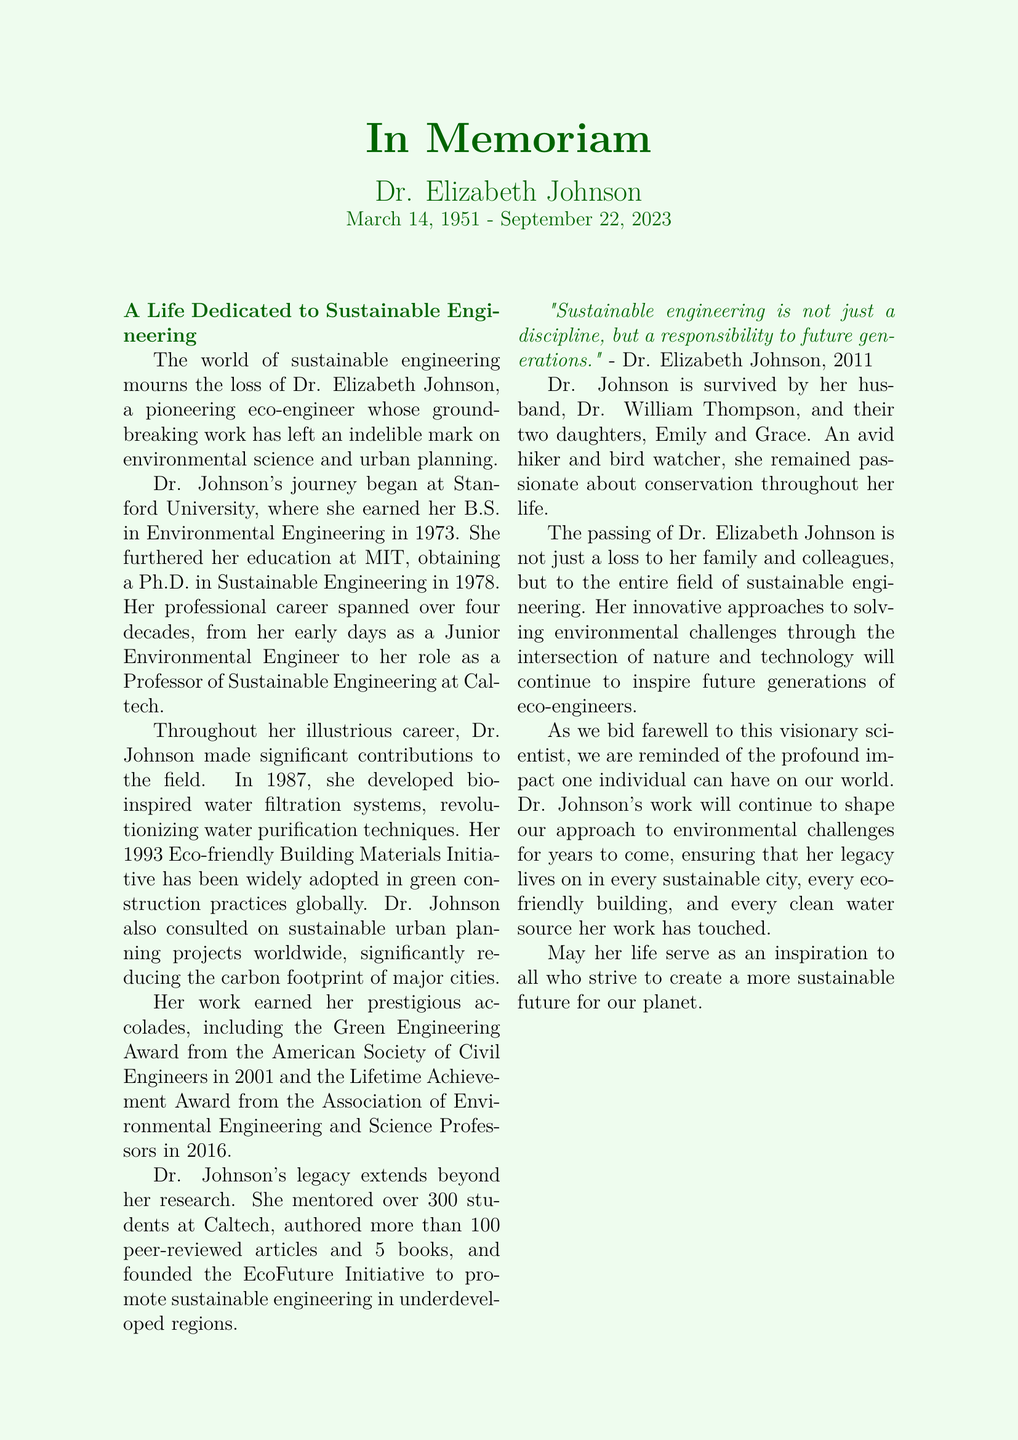What was Dr. Johnson's birth date? The document states that Dr. Elizabeth Johnson was born on March 14, 1951.
Answer: March 14, 1951 How many peer-reviewed articles did Dr. Johnson author? The document mentions that Dr. Johnson authored more than 100 peer-reviewed articles.
Answer: More than 100 What award did Dr. Johnson receive in 2001? The document lists the Green Engineering Award from the American Society of Civil Engineers as an accolade given to Dr. Johnson in 2001.
Answer: Green Engineering Award What was the name of the initiative Dr. Johnson founded? The document refers to the EcoFuture Initiative as the initiative founded by Dr. Johnson.
Answer: EcoFuture Initiative How many students did Dr. Johnson mentor? The document indicates that Dr. Johnson mentored over 300 students at Caltech.
Answer: Over 300 What was Dr. Johnson passionate about outside of her work? The document describes her as an avid hiker and bird watcher, highlighting her passion for conservation.
Answer: Conservation What university did Dr. Johnson attend for her Ph.D.? The document states that Dr. Johnson obtained her Ph.D. at MIT.
Answer: MIT What year did Dr. Johnson develop bio-inspired water filtration systems? The document notes that she developed these systems in 1987.
Answer: 1987 What does the document say about Dr. Johnson's impact? The document expresses that her innovative approaches will continue to inspire future generations of eco-engineers.
Answer: Inspire future generations 